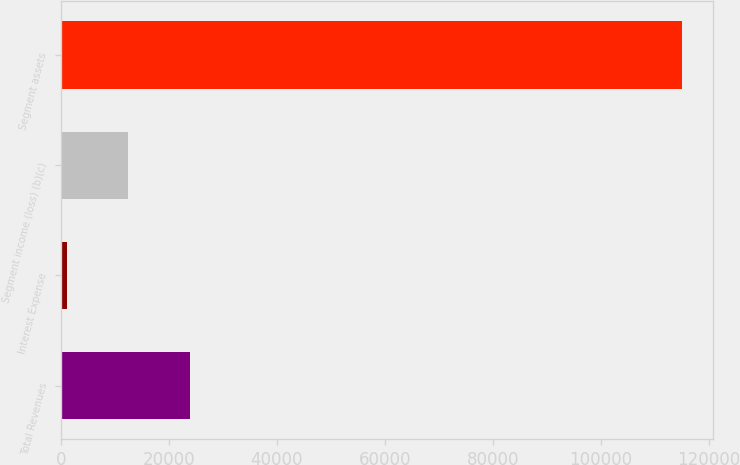Convert chart to OTSL. <chart><loc_0><loc_0><loc_500><loc_500><bar_chart><fcel>Total Revenues<fcel>Interest Expense<fcel>Segment income (loss) (b)(c)<fcel>Segment assets<nl><fcel>23907.4<fcel>1136<fcel>12521.7<fcel>114993<nl></chart> 